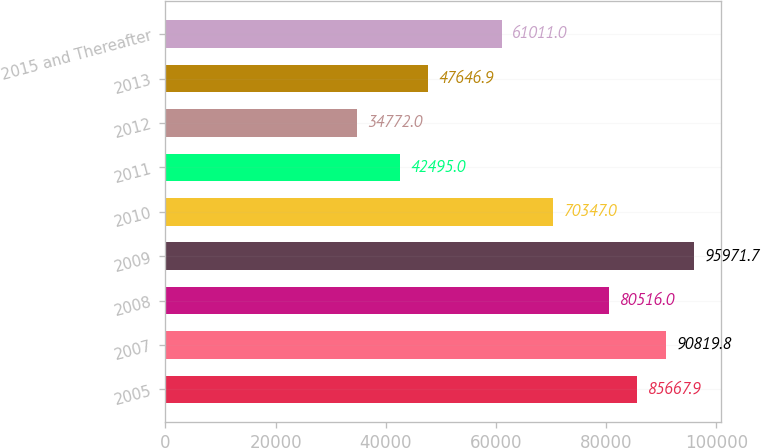Convert chart. <chart><loc_0><loc_0><loc_500><loc_500><bar_chart><fcel>2005<fcel>2007<fcel>2008<fcel>2009<fcel>2010<fcel>2011<fcel>2012<fcel>2013<fcel>2015 and Thereafter<nl><fcel>85667.9<fcel>90819.8<fcel>80516<fcel>95971.7<fcel>70347<fcel>42495<fcel>34772<fcel>47646.9<fcel>61011<nl></chart> 